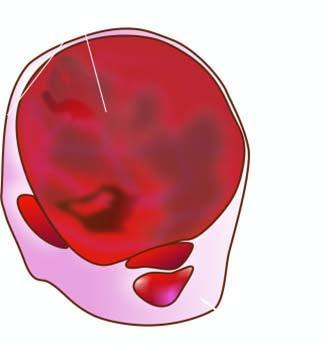what is enlarged diffusely?
Answer the question using a single word or phrase. Thyroid gland 